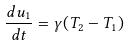Convert formula to latex. <formula><loc_0><loc_0><loc_500><loc_500>\frac { d u _ { 1 } } { d t } = \gamma ( T _ { 2 } - T _ { 1 } )</formula> 